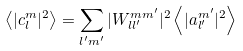<formula> <loc_0><loc_0><loc_500><loc_500>\left < | c _ { l } ^ { m } | ^ { 2 } \right > = \sum _ { l ^ { \prime } m ^ { \prime } } | W _ { l l ^ { \prime } } ^ { m m ^ { \prime } } | ^ { 2 } \left < | a _ { l ^ { \prime } } ^ { m ^ { \prime } } | ^ { 2 } \right ></formula> 